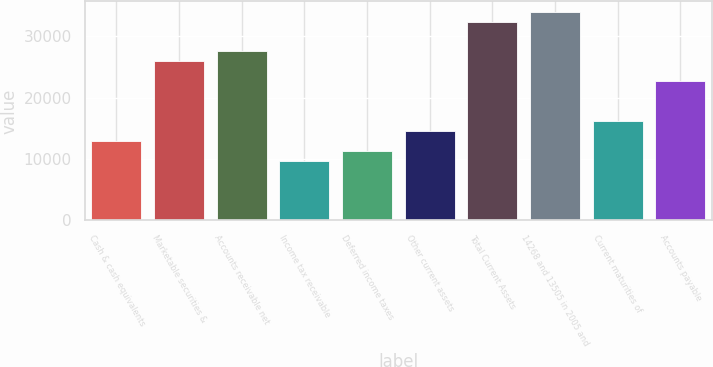<chart> <loc_0><loc_0><loc_500><loc_500><bar_chart><fcel>Cash & cash equivalents<fcel>Marketable securities &<fcel>Accounts receivable net<fcel>Income tax receivable<fcel>Deferred income taxes<fcel>Other current assets<fcel>Total Current Assets<fcel>14268 and 13505 in 2005 and<fcel>Current maturities of<fcel>Accounts payable<nl><fcel>12954.6<fcel>25904.2<fcel>27522.9<fcel>9717.2<fcel>11335.9<fcel>14573.3<fcel>32379<fcel>33997.7<fcel>16192<fcel>22666.8<nl></chart> 